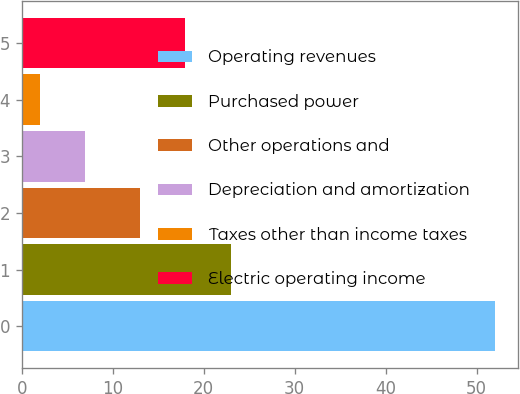Convert chart. <chart><loc_0><loc_0><loc_500><loc_500><bar_chart><fcel>Operating revenues<fcel>Purchased power<fcel>Other operations and<fcel>Depreciation and amortization<fcel>Taxes other than income taxes<fcel>Electric operating income<nl><fcel>52<fcel>23<fcel>13<fcel>7<fcel>2<fcel>18<nl></chart> 